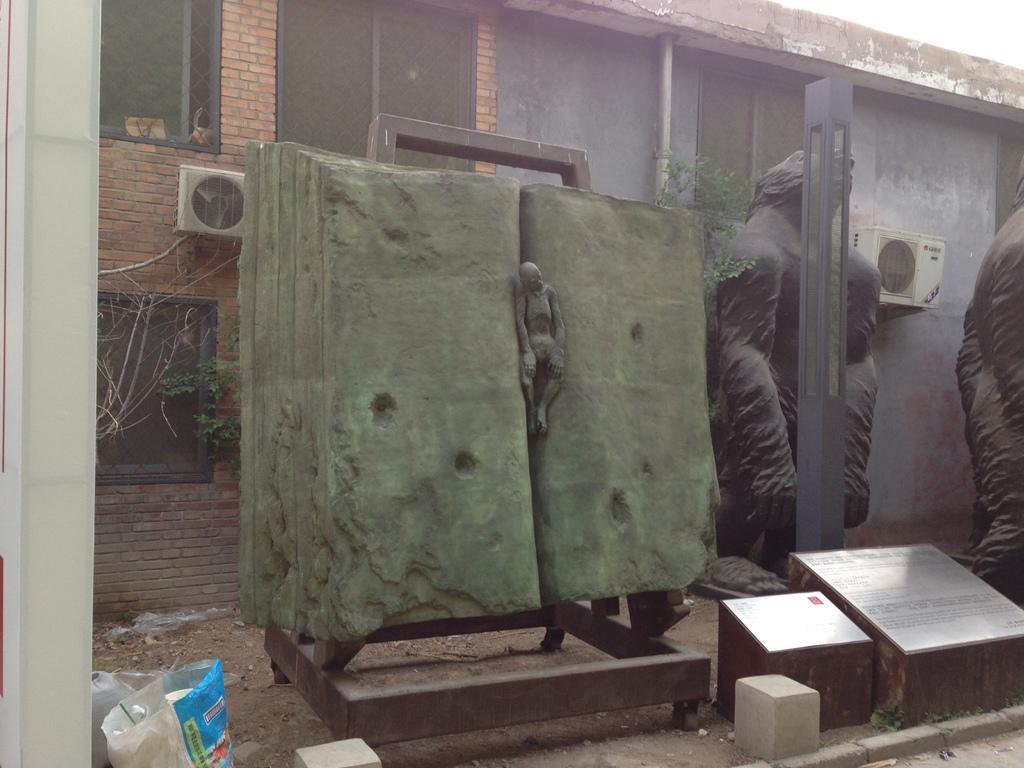Can you describe this image briefly? In this picture we can see there is a sculpture in between the two rocks. On the right side of the image, there are sculptures and a pole. Behind the rocks, there are plants and there is a building with windows. In the bottom left corner of the image, there is a sack, a pole and an object. 